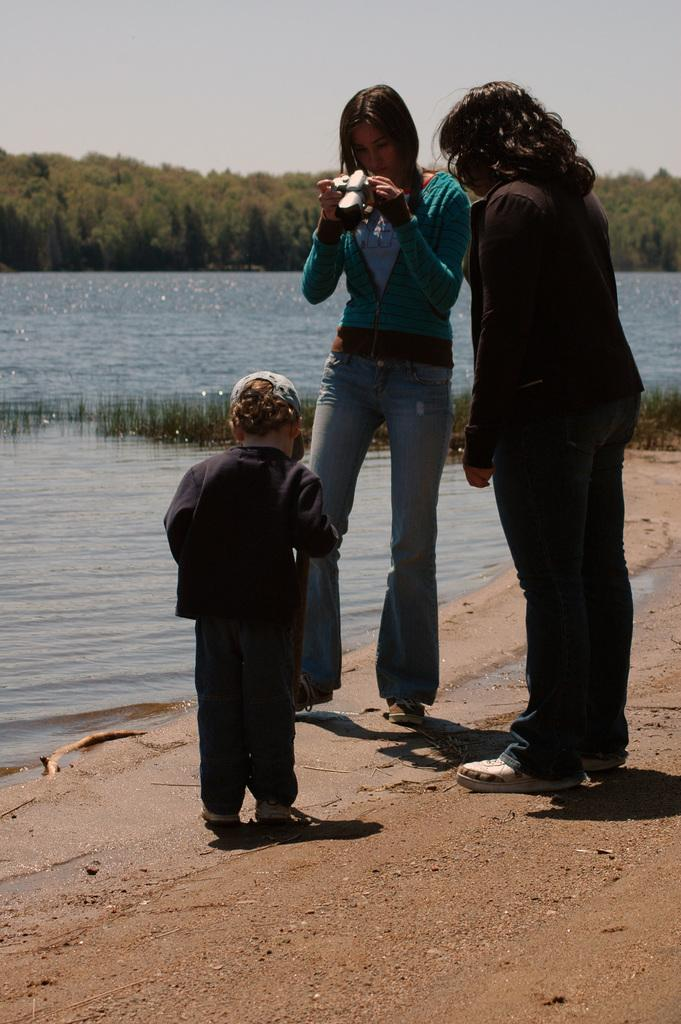How many people are in the image? There are people in the image, but the exact number is not specified. What is the person holding in the image? A person is holding an object, but the specific object is not described. What can be seen in the background of the image? There is water and sky visible in the image, as well as many trees. What type of cracker is being eaten in the image? There is no cracker present in the image. What is the reason for the people gathering in the image? The reason for the people gathering is not mentioned in the image. 